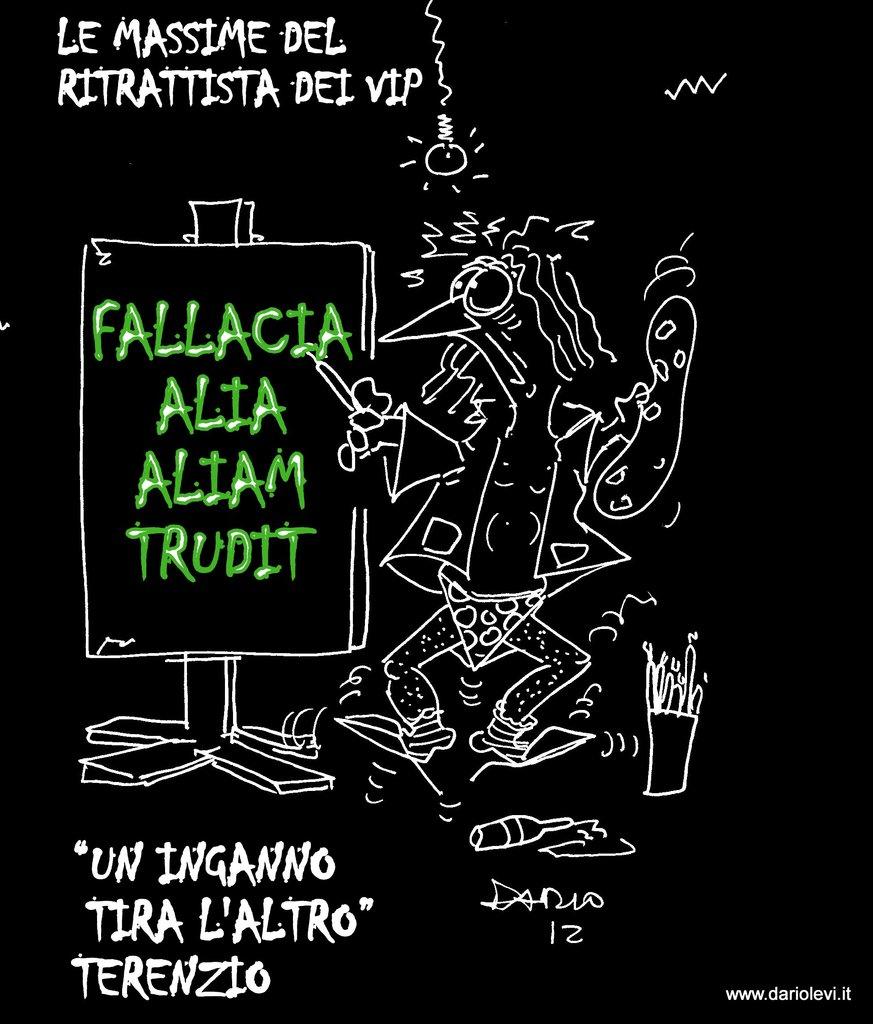Are the words on the sign in english?
Your answer should be compact. No. What is written in green?
Ensure brevity in your answer.  Fallacia alia aliam trudit. 